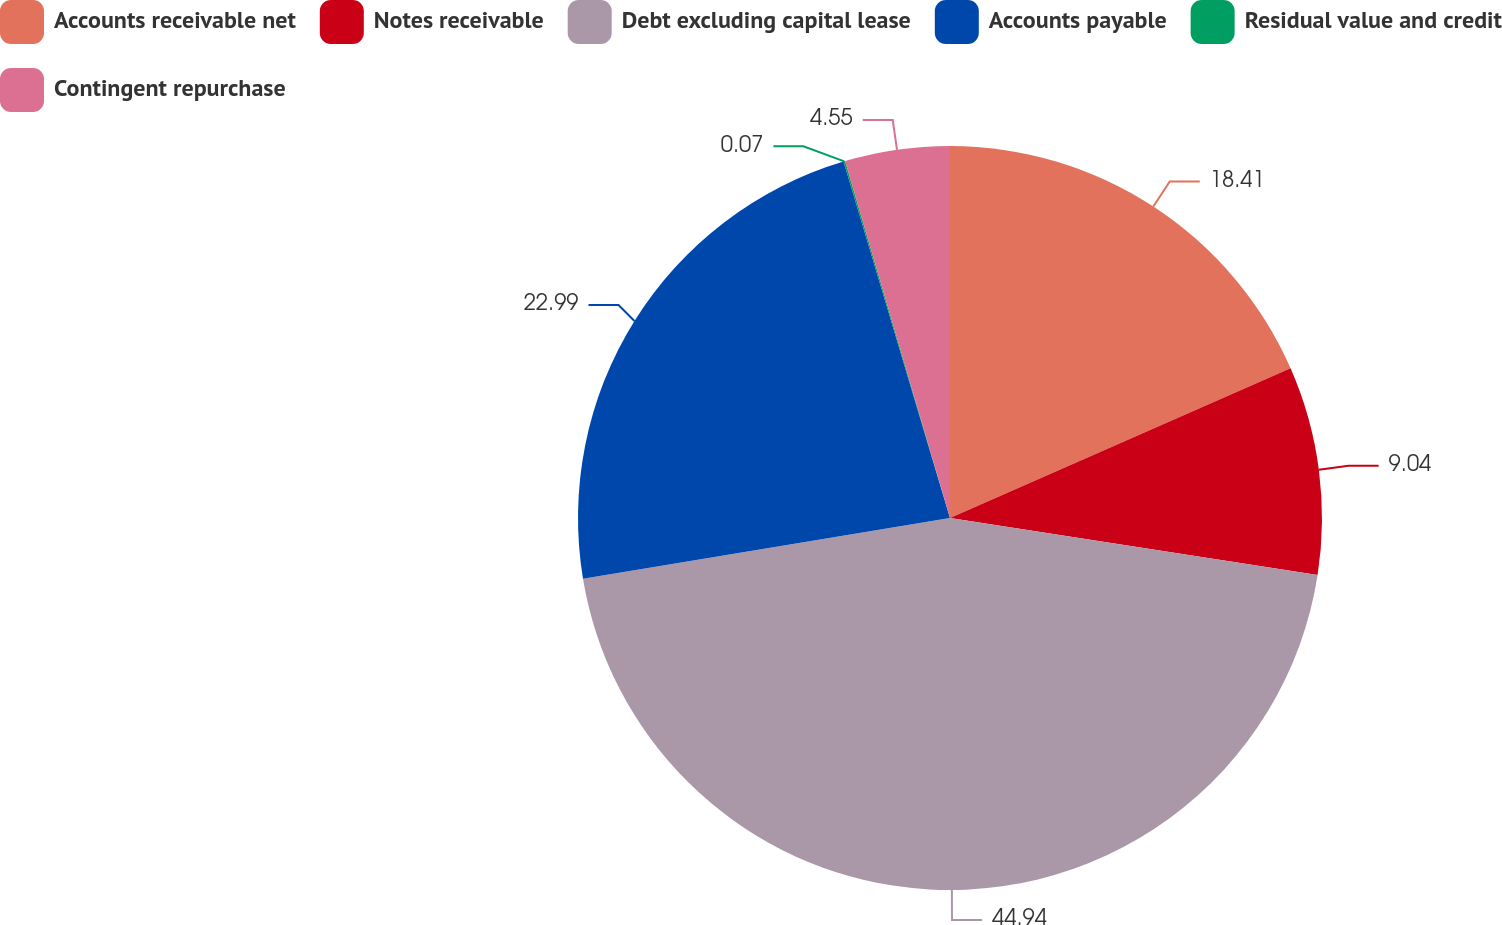Convert chart to OTSL. <chart><loc_0><loc_0><loc_500><loc_500><pie_chart><fcel>Accounts receivable net<fcel>Notes receivable<fcel>Debt excluding capital lease<fcel>Accounts payable<fcel>Residual value and credit<fcel>Contingent repurchase<nl><fcel>18.41%<fcel>9.04%<fcel>44.94%<fcel>22.99%<fcel>0.07%<fcel>4.55%<nl></chart> 